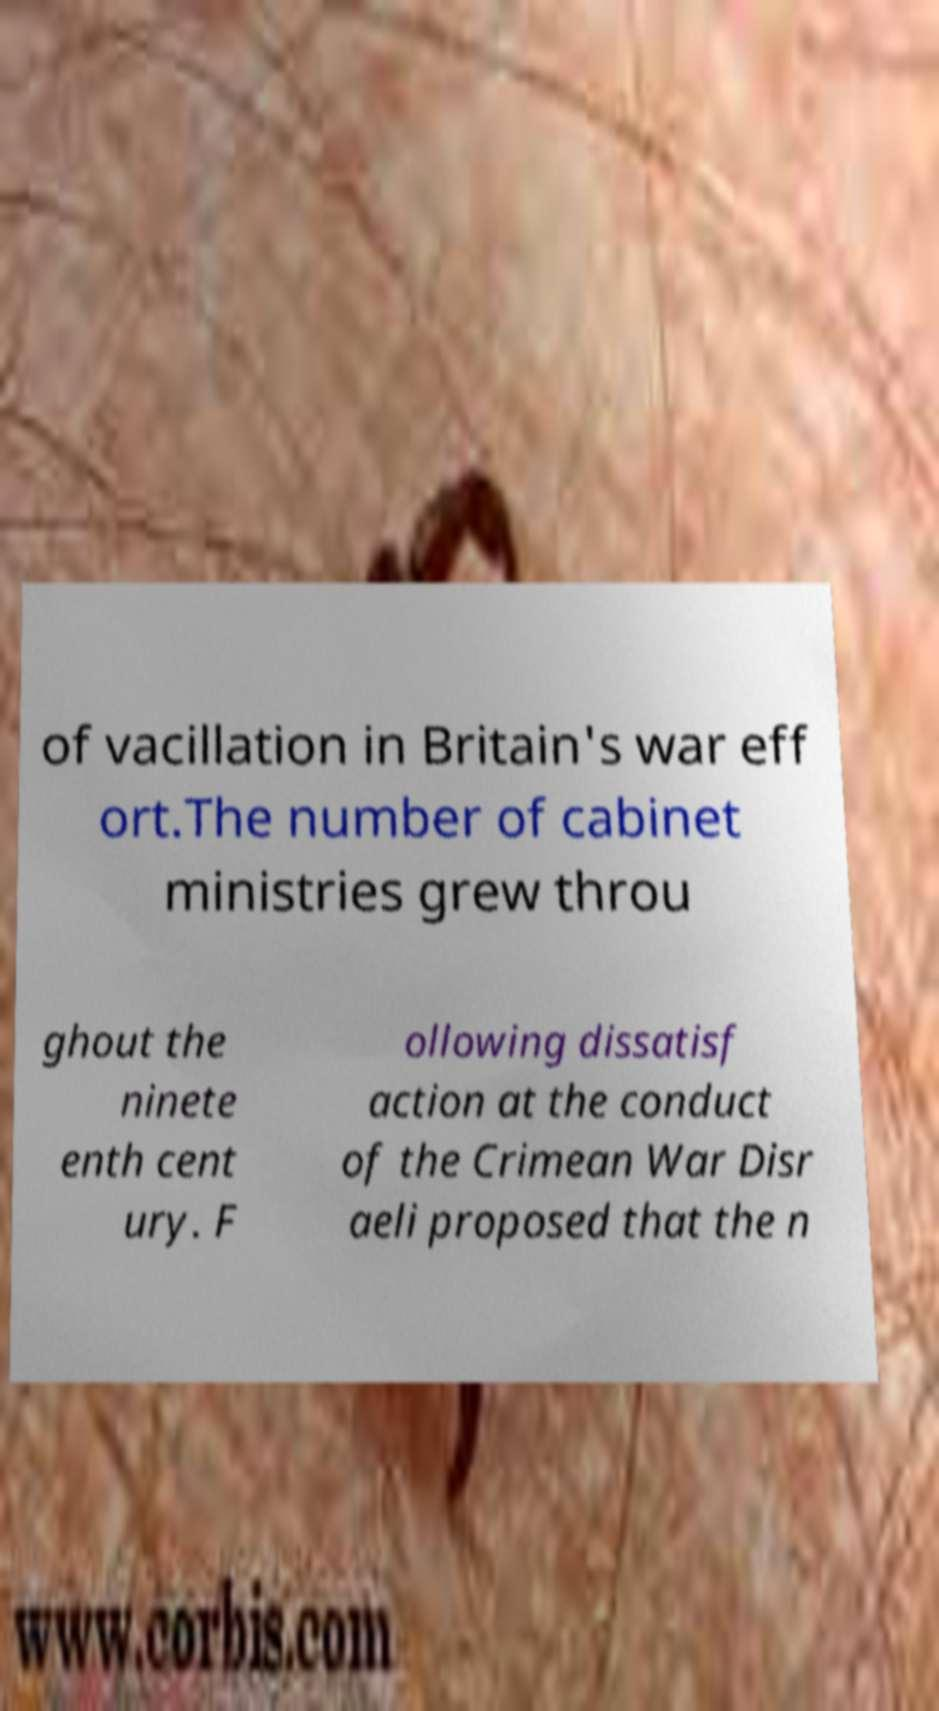For documentation purposes, I need the text within this image transcribed. Could you provide that? of vacillation in Britain's war eff ort.The number of cabinet ministries grew throu ghout the ninete enth cent ury. F ollowing dissatisf action at the conduct of the Crimean War Disr aeli proposed that the n 